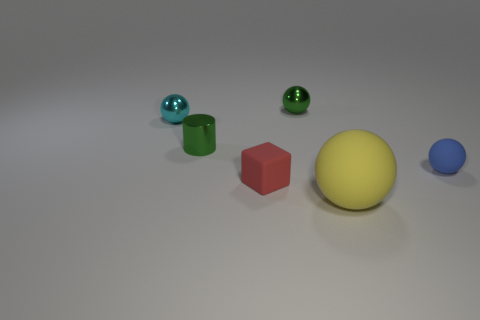What could this image represent or symbolize, from an abstract perspective? This image could symbolize various concepts. The different shapes and colors might represent diversity and individuality in a harmonious space, as they coexist peacefully. Alternatively, the layout of the objects could represent a solar system, with the yellow sphere as a sun and the other colored shapes as planets, each with a unique path and characteristic. 